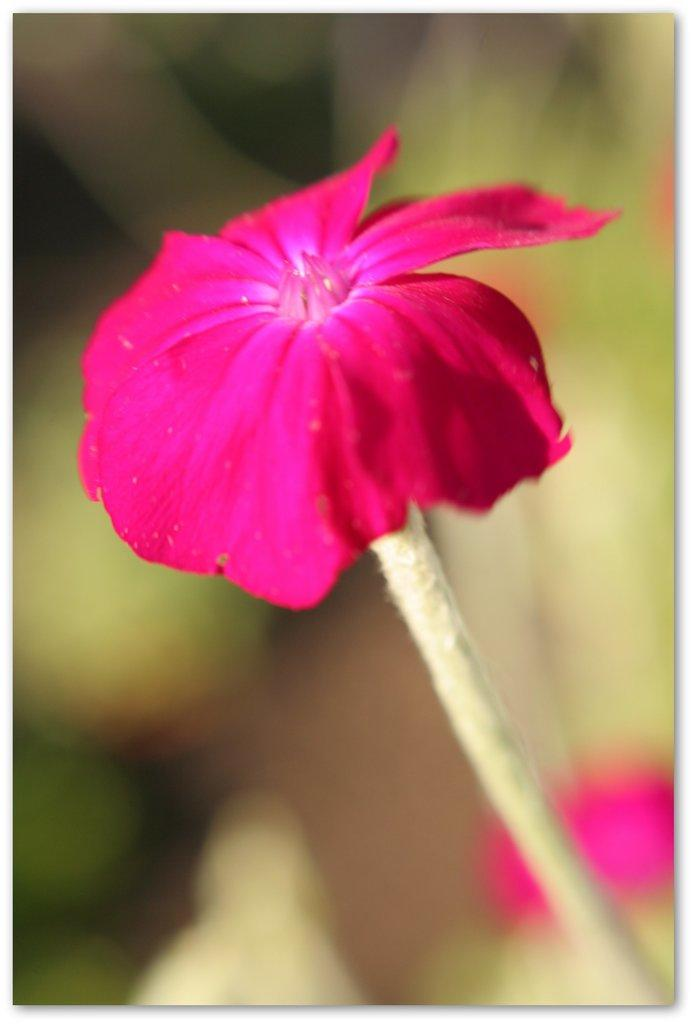What type of flower is in the image? There is a pink flower in the image. Can you describe the background of the image? The background is blurred and green. What type of tools does the carpenter use in the image? There is no carpenter present in the image, so it is not possible to answer that question. 